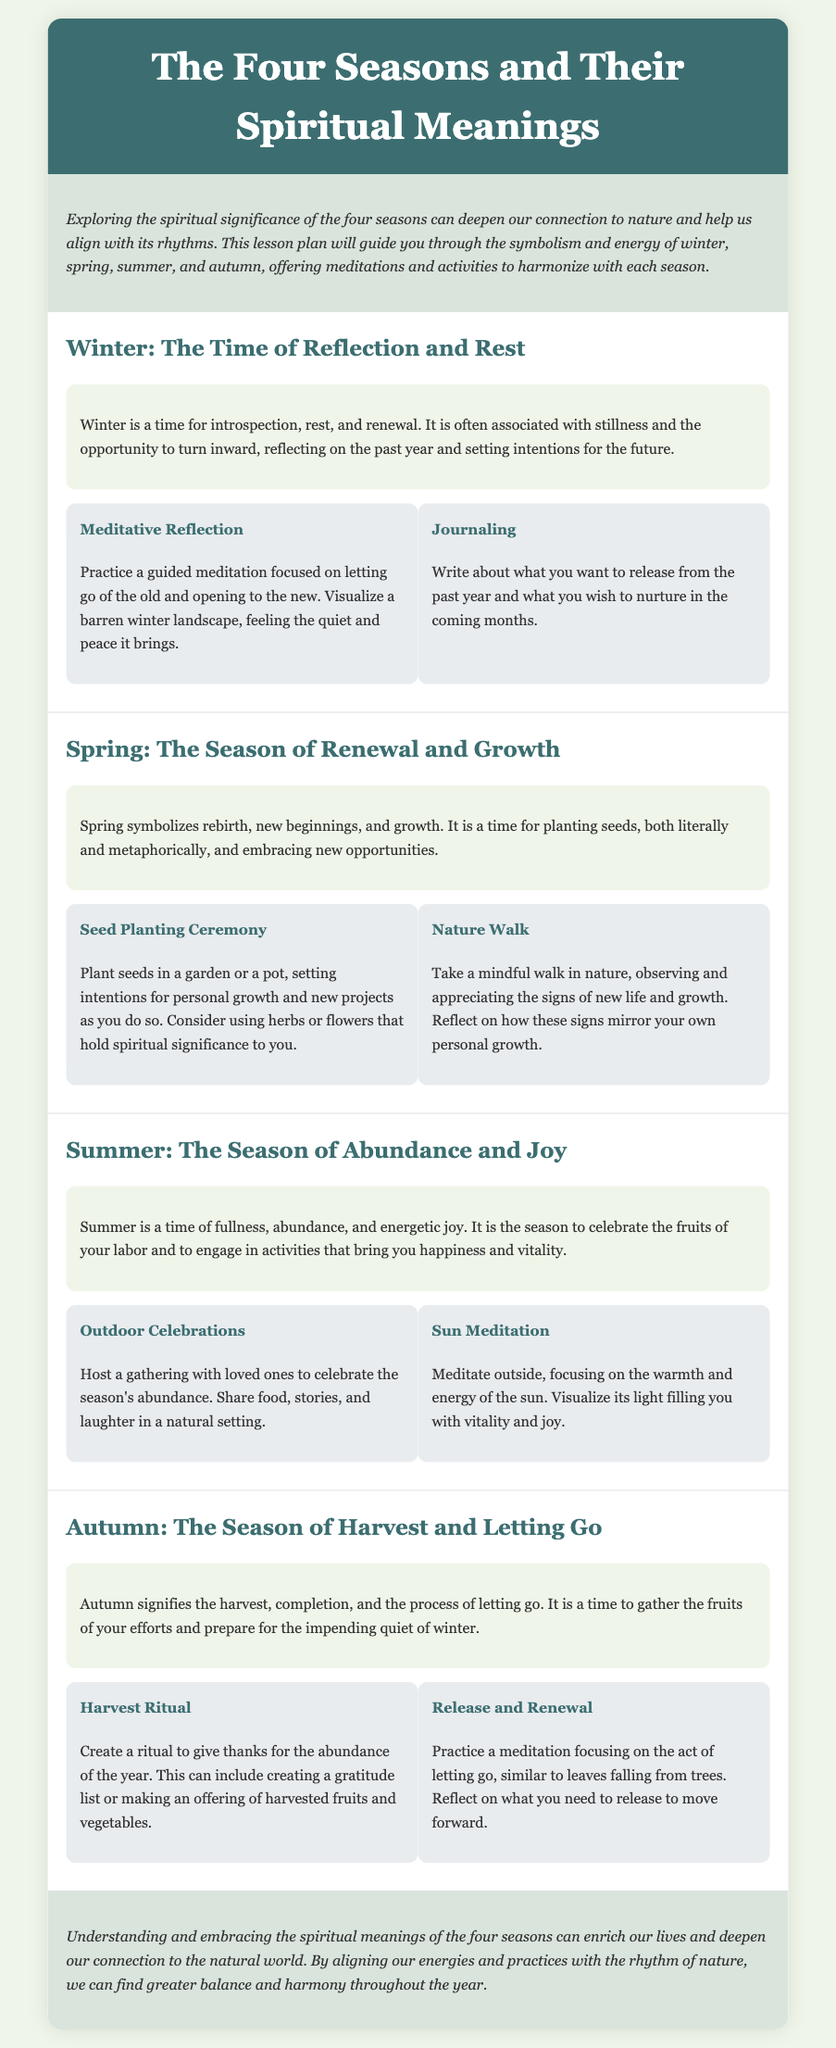What is the spiritual meaning of winter? The spiritual meaning of winter is introspection, rest, and renewal.
Answer: introspection, rest, and renewal What activity is suggested for spring? The activities suggested for spring include a Seed Planting Ceremony and a Nature Walk.
Answer: Seed Planting Ceremony What is the primary focus of summer? The primary focus of summer is abundance and joy.
Answer: abundance and joy What does autumn signify? Autumn signifies the harvest, completion, and the process of letting go.
Answer: harvest, completion, and letting go What meditation practice is recommended for winter? The recommended meditation practice for winter is a guided meditation focused on letting go of the old and opening to the new.
Answer: guided meditation How many activities are proposed for each season? Each season proposes two activities.
Answer: two Which season is associated with rebirth? The season associated with rebirth is spring.
Answer: spring What is the conclusion of the lesson plan? The conclusion emphasizes that understanding and embracing the spiritual meanings of the four seasons enrich our lives and deepen our connection to nature.
Answer: enrich our lives and deepen our connection to nature 